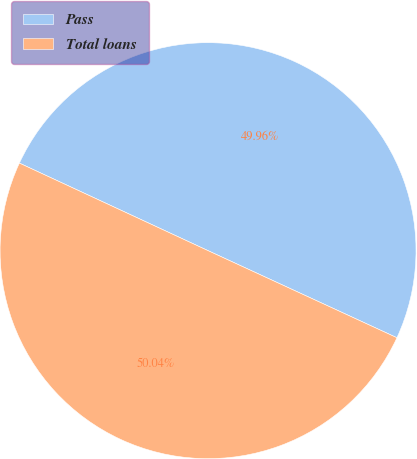Convert chart. <chart><loc_0><loc_0><loc_500><loc_500><pie_chart><fcel>Pass<fcel>Total loans<nl><fcel>49.96%<fcel>50.04%<nl></chart> 